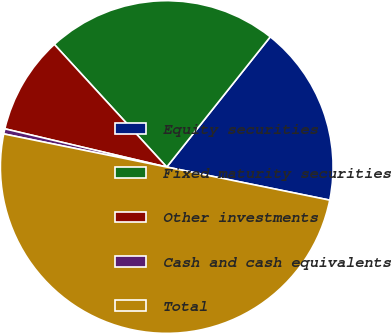<chart> <loc_0><loc_0><loc_500><loc_500><pie_chart><fcel>Equity securities<fcel>Fixed maturity securities<fcel>Other investments<fcel>Cash and cash equivalents<fcel>Total<nl><fcel>17.5%<fcel>22.5%<fcel>9.5%<fcel>0.5%<fcel>50.0%<nl></chart> 